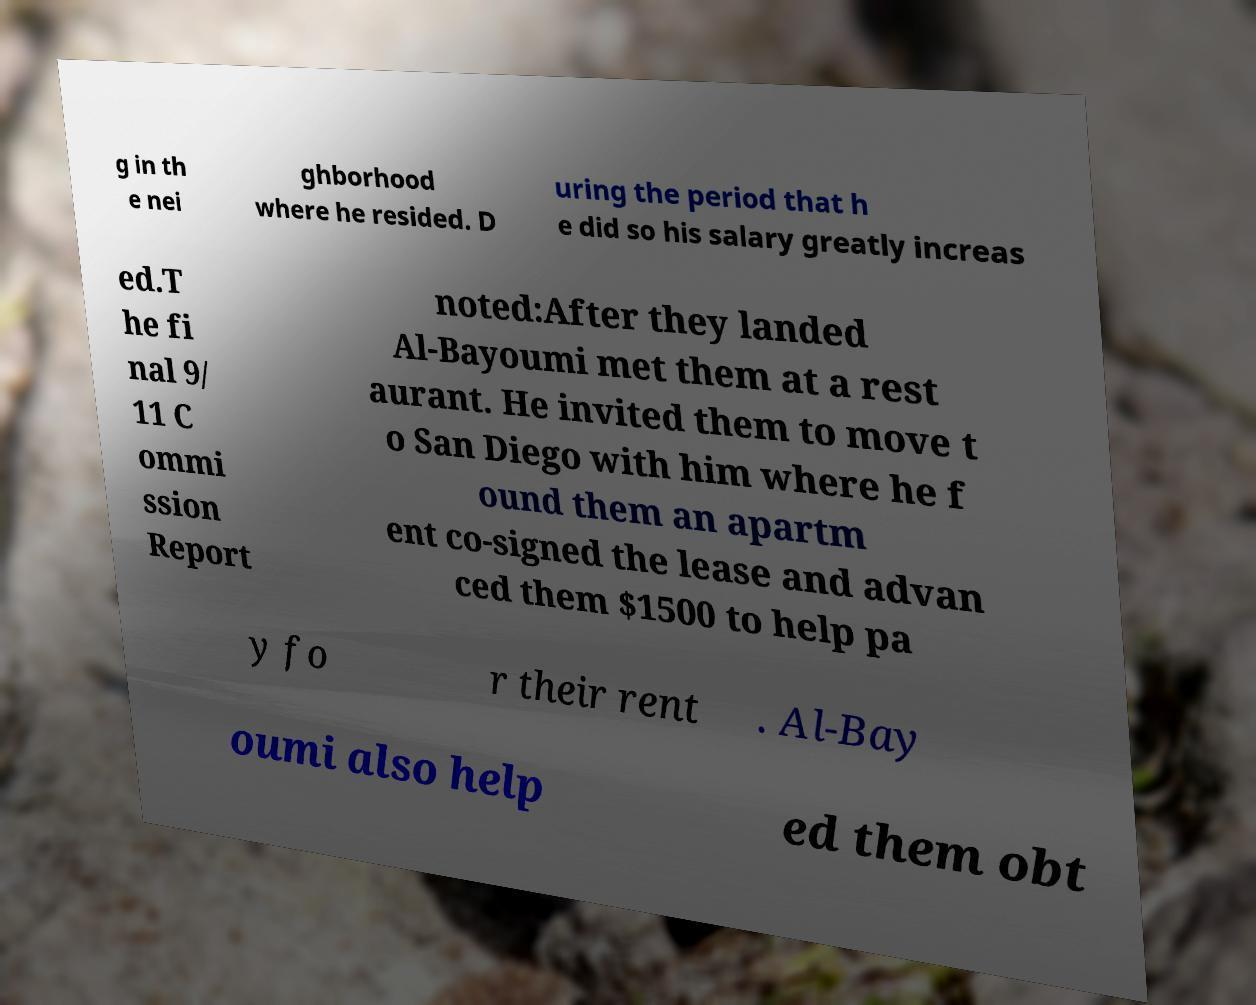Please read and relay the text visible in this image. What does it say? g in th e nei ghborhood where he resided. D uring the period that h e did so his salary greatly increas ed.T he fi nal 9/ 11 C ommi ssion Report noted:After they landed Al-Bayoumi met them at a rest aurant. He invited them to move t o San Diego with him where he f ound them an apartm ent co-signed the lease and advan ced them $1500 to help pa y fo r their rent . Al-Bay oumi also help ed them obt 